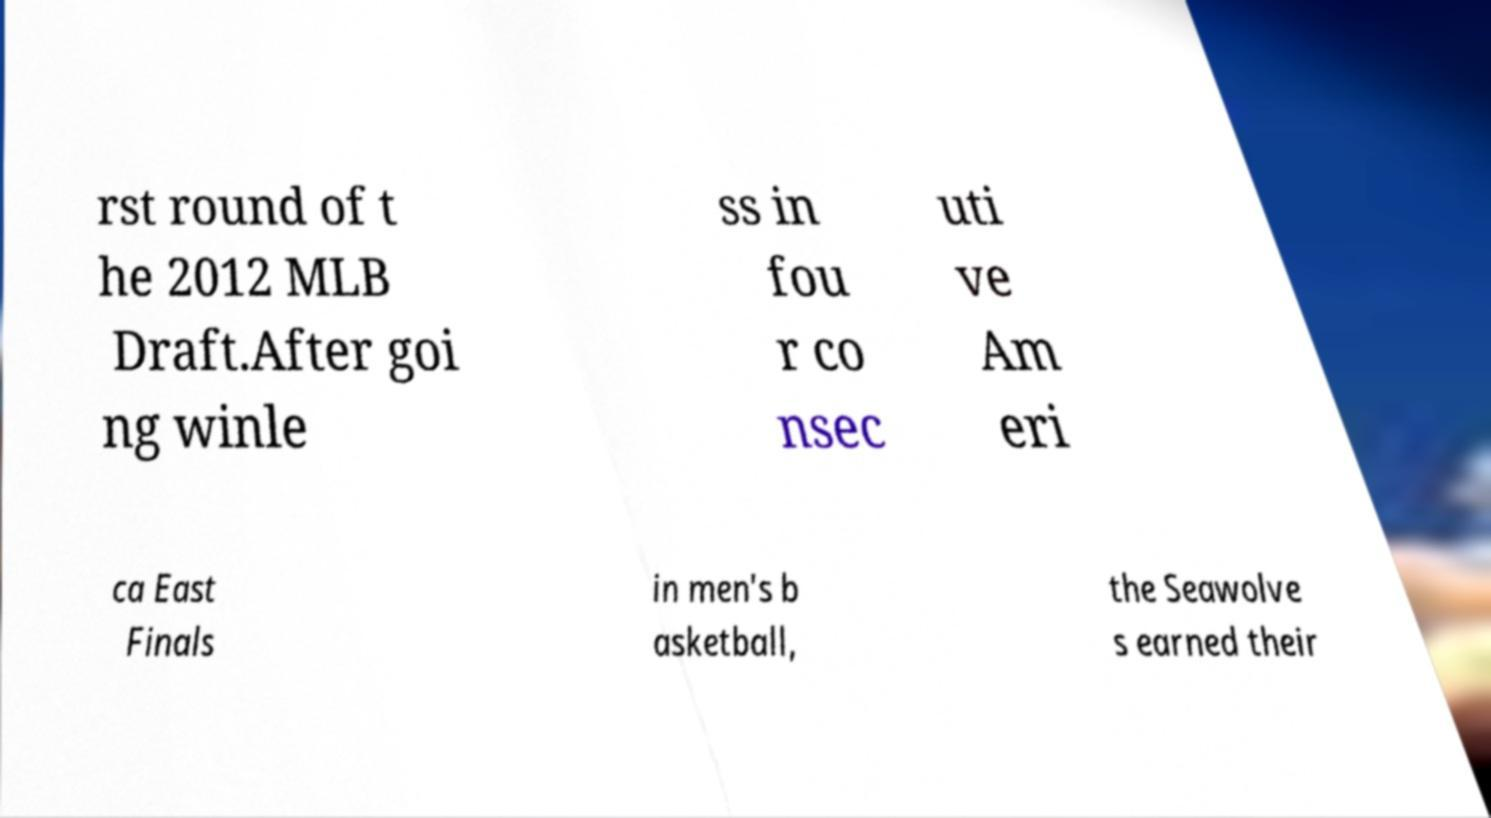Can you accurately transcribe the text from the provided image for me? rst round of t he 2012 MLB Draft.After goi ng winle ss in fou r co nsec uti ve Am eri ca East Finals in men's b asketball, the Seawolve s earned their 